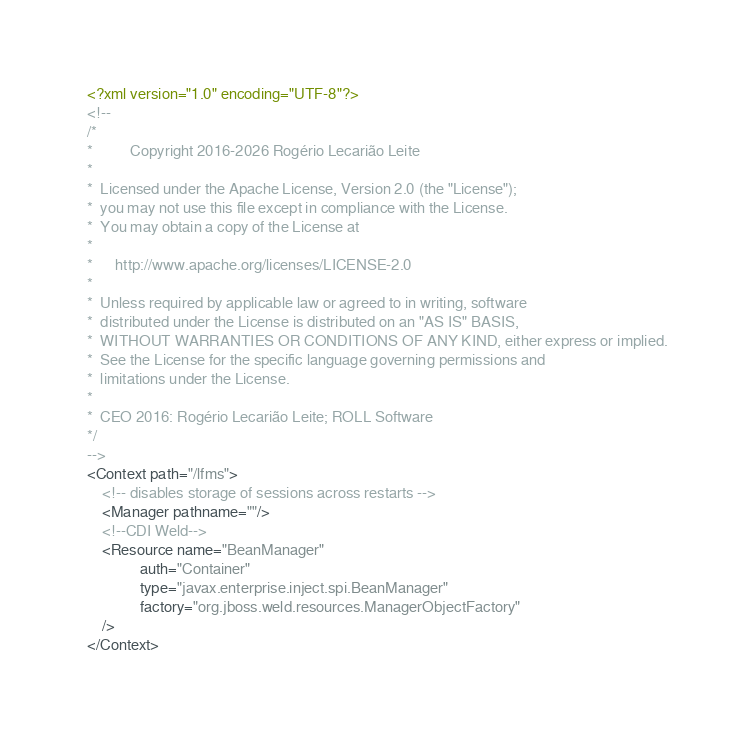Convert code to text. <code><loc_0><loc_0><loc_500><loc_500><_XML_><?xml version="1.0" encoding="UTF-8"?>
<!--
/*
*          Copyright 2016-2026 Rogério Lecarião Leite
*
*  Licensed under the Apache License, Version 2.0 (the "License");
*  you may not use this file except in compliance with the License.
*  You may obtain a copy of the License at
*
*      http://www.apache.org/licenses/LICENSE-2.0
*
*  Unless required by applicable law or agreed to in writing, software
*  distributed under the License is distributed on an "AS IS" BASIS,
*  WITHOUT WARRANTIES OR CONDITIONS OF ANY KIND, either express or implied.
*  See the License for the specific language governing permissions and
*  limitations under the License.
*
*  CEO 2016: Rogério Lecarião Leite; ROLL Software
*/
-->
<Context path="/lfms">
    <!-- disables storage of sessions across restarts -->
    <Manager pathname=""/>
    <!--CDI Weld-->
    <Resource name="BeanManager"
              auth="Container"
              type="javax.enterprise.inject.spi.BeanManager"
              factory="org.jboss.weld.resources.ManagerObjectFactory"
    />
</Context>
</code> 